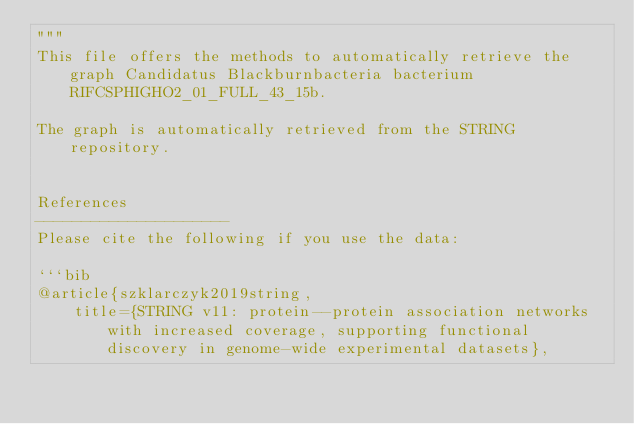Convert code to text. <code><loc_0><loc_0><loc_500><loc_500><_Python_>"""
This file offers the methods to automatically retrieve the graph Candidatus Blackburnbacteria bacterium RIFCSPHIGHO2_01_FULL_43_15b.

The graph is automatically retrieved from the STRING repository. 


References
---------------------
Please cite the following if you use the data:

```bib
@article{szklarczyk2019string,
    title={STRING v11: protein--protein association networks with increased coverage, supporting functional discovery in genome-wide experimental datasets},</code> 